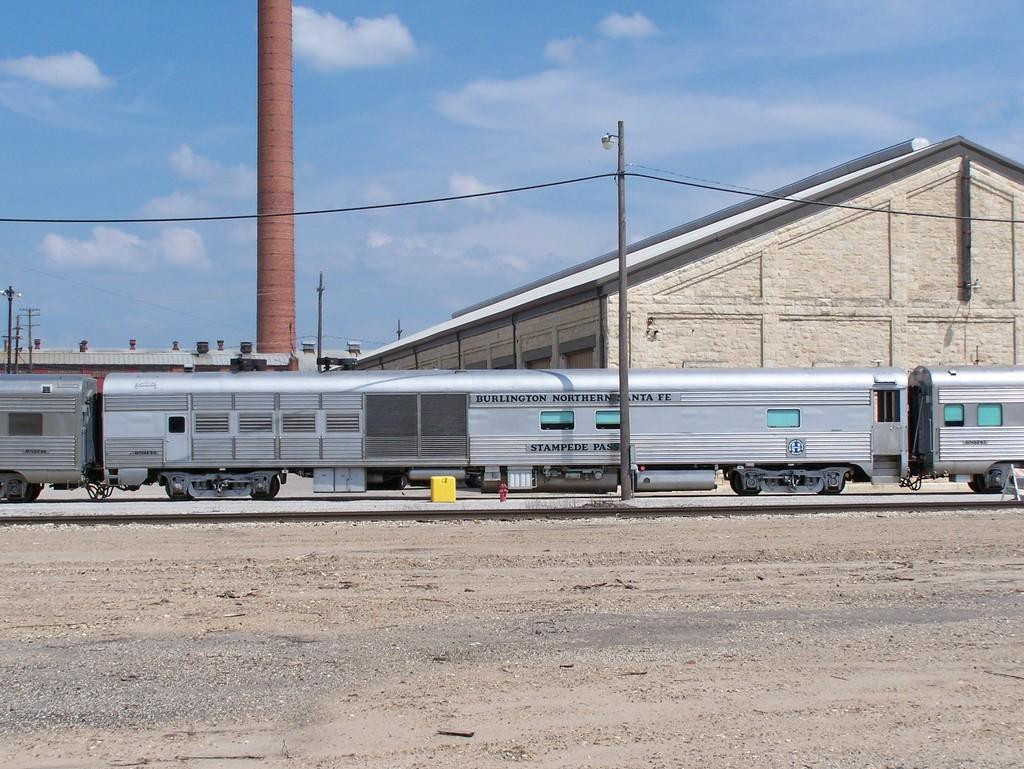<image>
Render a clear and concise summary of the photo. a Burlington northern Santa fe train passing by a warehouse. 